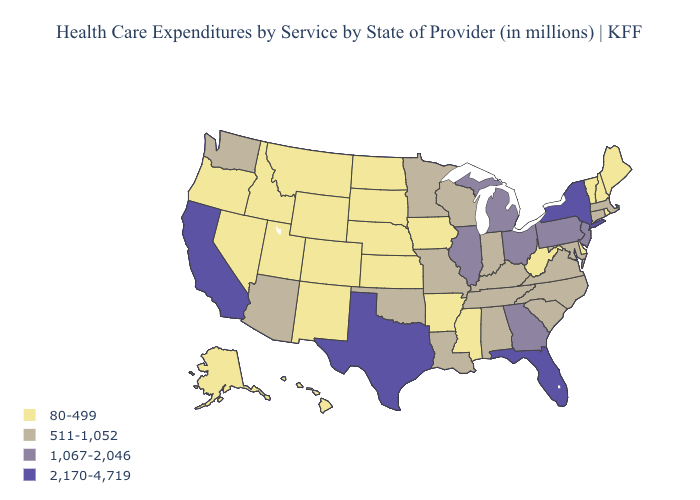Name the states that have a value in the range 1,067-2,046?
Answer briefly. Georgia, Illinois, Michigan, New Jersey, Ohio, Pennsylvania. What is the value of Arkansas?
Concise answer only. 80-499. Does Virginia have the lowest value in the USA?
Give a very brief answer. No. Which states have the lowest value in the USA?
Write a very short answer. Alaska, Arkansas, Colorado, Delaware, Hawaii, Idaho, Iowa, Kansas, Maine, Mississippi, Montana, Nebraska, Nevada, New Hampshire, New Mexico, North Dakota, Oregon, Rhode Island, South Dakota, Utah, Vermont, West Virginia, Wyoming. Which states have the highest value in the USA?
Write a very short answer. California, Florida, New York, Texas. Name the states that have a value in the range 1,067-2,046?
Write a very short answer. Georgia, Illinois, Michigan, New Jersey, Ohio, Pennsylvania. What is the value of Michigan?
Answer briefly. 1,067-2,046. Among the states that border Wisconsin , which have the highest value?
Write a very short answer. Illinois, Michigan. Name the states that have a value in the range 1,067-2,046?
Quick response, please. Georgia, Illinois, Michigan, New Jersey, Ohio, Pennsylvania. What is the lowest value in states that border Virginia?
Answer briefly. 80-499. Which states have the lowest value in the USA?
Short answer required. Alaska, Arkansas, Colorado, Delaware, Hawaii, Idaho, Iowa, Kansas, Maine, Mississippi, Montana, Nebraska, Nevada, New Hampshire, New Mexico, North Dakota, Oregon, Rhode Island, South Dakota, Utah, Vermont, West Virginia, Wyoming. Among the states that border West Virginia , which have the lowest value?
Answer briefly. Kentucky, Maryland, Virginia. Does California have the highest value in the West?
Answer briefly. Yes. Name the states that have a value in the range 80-499?
Concise answer only. Alaska, Arkansas, Colorado, Delaware, Hawaii, Idaho, Iowa, Kansas, Maine, Mississippi, Montana, Nebraska, Nevada, New Hampshire, New Mexico, North Dakota, Oregon, Rhode Island, South Dakota, Utah, Vermont, West Virginia, Wyoming. What is the value of California?
Be succinct. 2,170-4,719. 